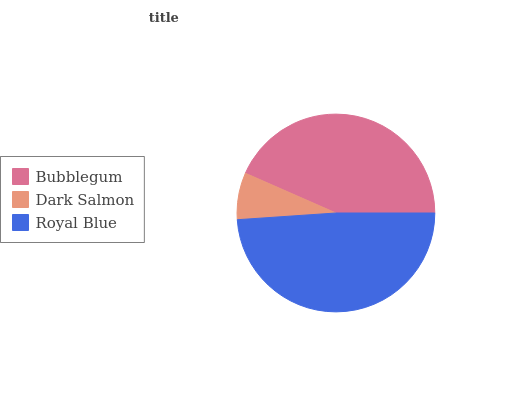Is Dark Salmon the minimum?
Answer yes or no. Yes. Is Royal Blue the maximum?
Answer yes or no. Yes. Is Royal Blue the minimum?
Answer yes or no. No. Is Dark Salmon the maximum?
Answer yes or no. No. Is Royal Blue greater than Dark Salmon?
Answer yes or no. Yes. Is Dark Salmon less than Royal Blue?
Answer yes or no. Yes. Is Dark Salmon greater than Royal Blue?
Answer yes or no. No. Is Royal Blue less than Dark Salmon?
Answer yes or no. No. Is Bubblegum the high median?
Answer yes or no. Yes. Is Bubblegum the low median?
Answer yes or no. Yes. Is Dark Salmon the high median?
Answer yes or no. No. Is Royal Blue the low median?
Answer yes or no. No. 